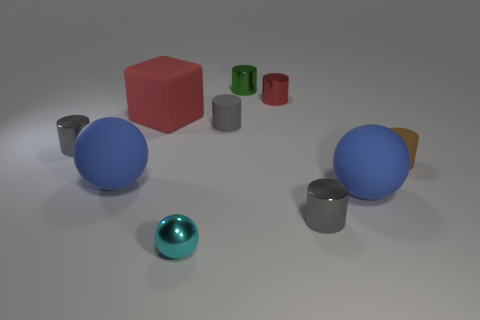How many blue things are large balls or small cylinders?
Provide a short and direct response. 2. There is a cyan thing that is the same size as the red metal cylinder; what is it made of?
Ensure brevity in your answer.  Metal. The matte object that is both in front of the tiny brown cylinder and to the left of the red metallic thing has what shape?
Ensure brevity in your answer.  Sphere. What color is the matte thing that is the same size as the gray matte cylinder?
Your answer should be compact. Brown. There is a gray thing that is left of the big block; is it the same size as the gray metallic cylinder to the right of the tiny metallic ball?
Offer a terse response. Yes. There is a gray thing that is on the left side of the big red rubber block that is behind the blue ball on the left side of the small cyan ball; how big is it?
Provide a short and direct response. Small. The big blue object that is on the left side of the blue rubber thing that is on the right side of the tiny cyan object is what shape?
Provide a succinct answer. Sphere. The thing that is to the left of the small sphere and behind the gray matte cylinder is what color?
Your response must be concise. Red. Are there any tiny cylinders made of the same material as the tiny cyan ball?
Offer a very short reply. Yes. The brown thing is what size?
Keep it short and to the point. Small. 